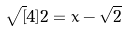<formula> <loc_0><loc_0><loc_500><loc_500>\sqrt { [ } 4 ] { 2 } = x - \sqrt { 2 }</formula> 